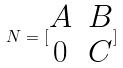Convert formula to latex. <formula><loc_0><loc_0><loc_500><loc_500>N = [ \begin{matrix} A & B \\ 0 & C \end{matrix} ]</formula> 